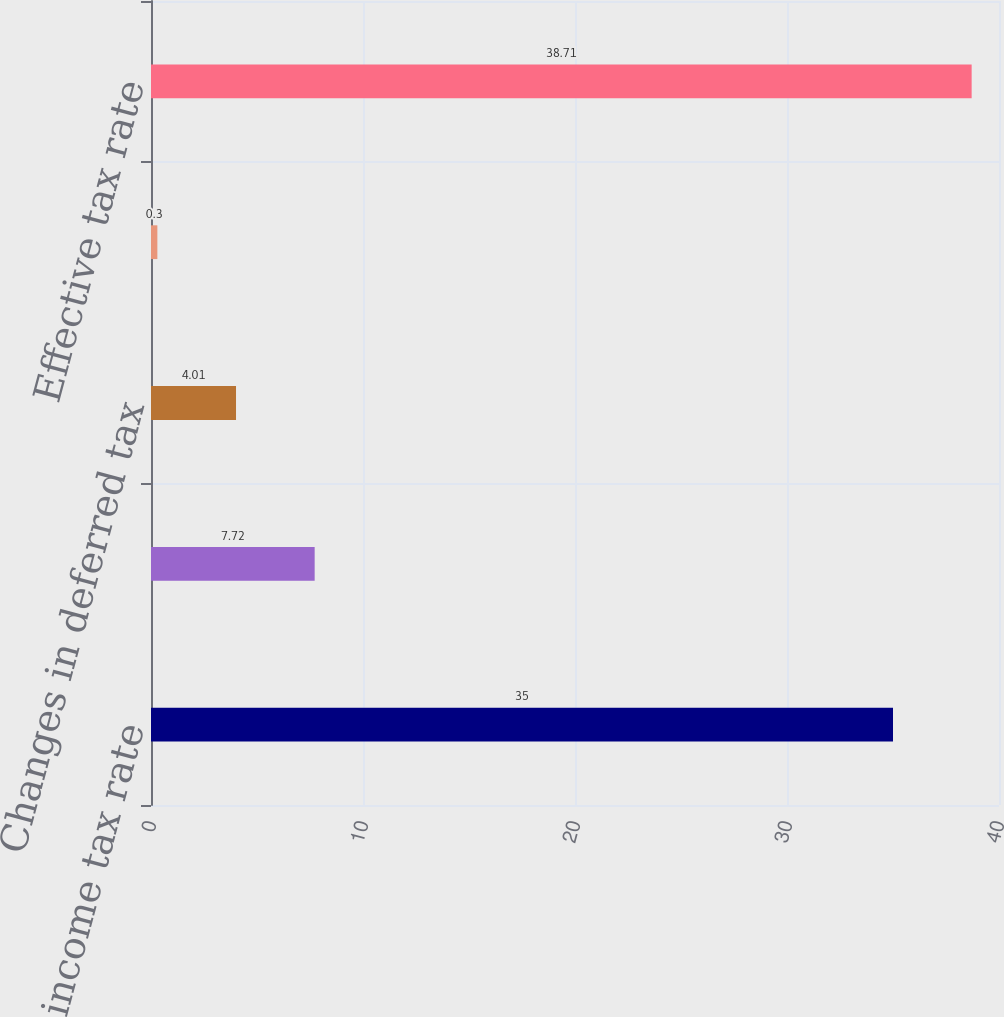Convert chart to OTSL. <chart><loc_0><loc_0><loc_500><loc_500><bar_chart><fcel>Federal income tax rate<fcel>State taxes net of federal<fcel>Changes in deferred tax<fcel>Other<fcel>Effective tax rate<nl><fcel>35<fcel>7.72<fcel>4.01<fcel>0.3<fcel>38.71<nl></chart> 